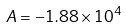Convert formula to latex. <formula><loc_0><loc_0><loc_500><loc_500>A = - 1 . 8 8 \times 1 0 ^ { 4 }</formula> 